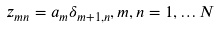Convert formula to latex. <formula><loc_0><loc_0><loc_500><loc_500>z _ { m n } = a _ { m } \delta _ { m + 1 , n } , m , n = 1 , \dots N</formula> 